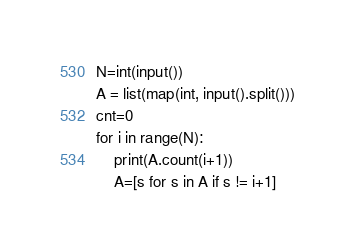Convert code to text. <code><loc_0><loc_0><loc_500><loc_500><_Python_>N=int(input())
A = list(map(int, input().split()))
cnt=0
for i in range(N):
    print(A.count(i+1))
    A=[s for s in A if s != i+1]</code> 